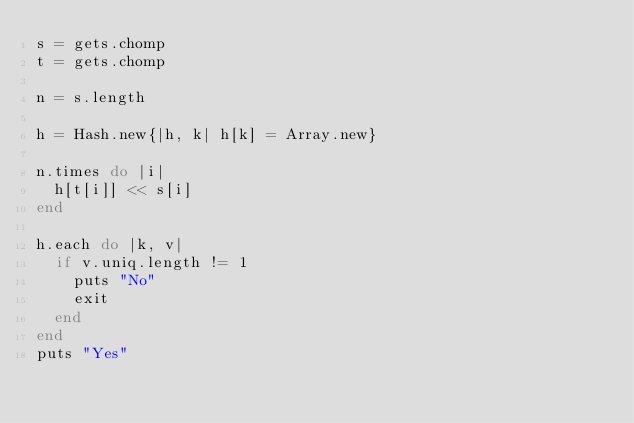Convert code to text. <code><loc_0><loc_0><loc_500><loc_500><_Ruby_>s = gets.chomp
t = gets.chomp

n = s.length

h = Hash.new{|h, k| h[k] = Array.new}

n.times do |i|
  h[t[i]] << s[i]
end

h.each do |k, v|
  if v.uniq.length != 1
    puts "No"
    exit
  end
end
puts "Yes"</code> 